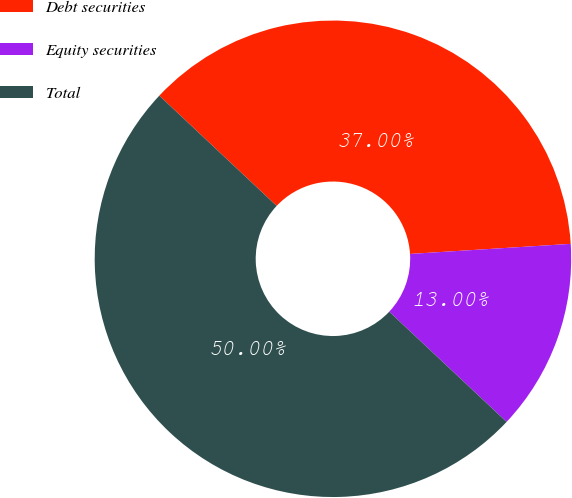Convert chart. <chart><loc_0><loc_0><loc_500><loc_500><pie_chart><fcel>Debt securities<fcel>Equity securities<fcel>Total<nl><fcel>37.0%<fcel>13.0%<fcel>50.0%<nl></chart> 